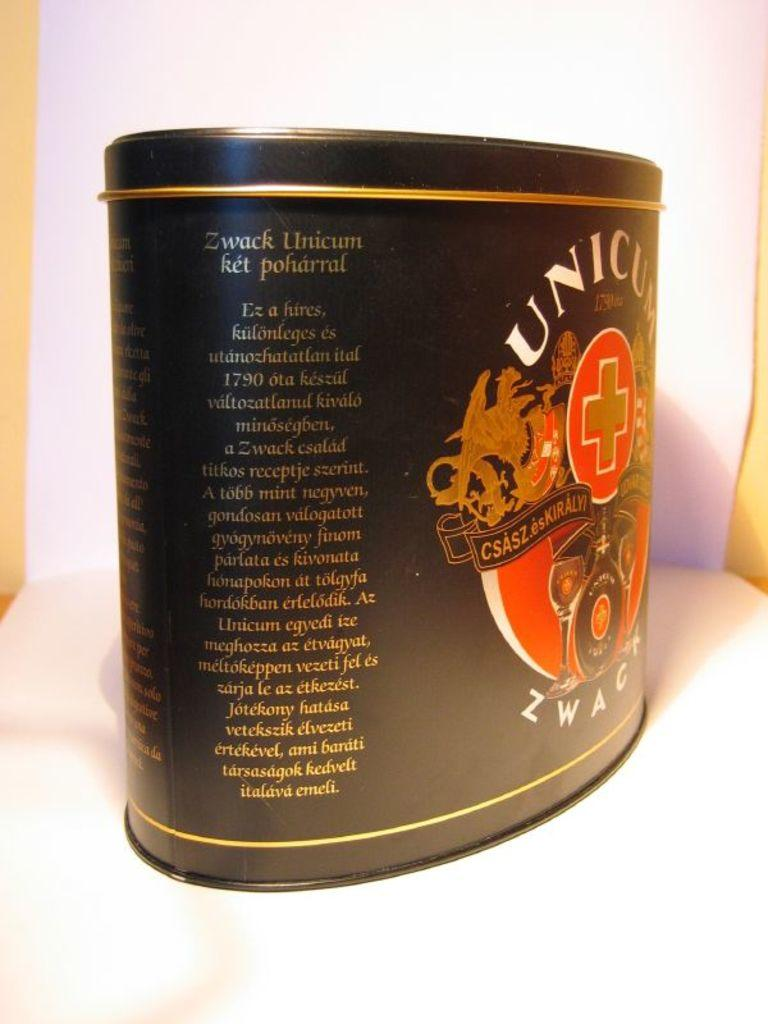<image>
Give a short and clear explanation of the subsequent image. A black, red and gold tin has the words "Zwack Unicum ket poharral" on the side of it. 